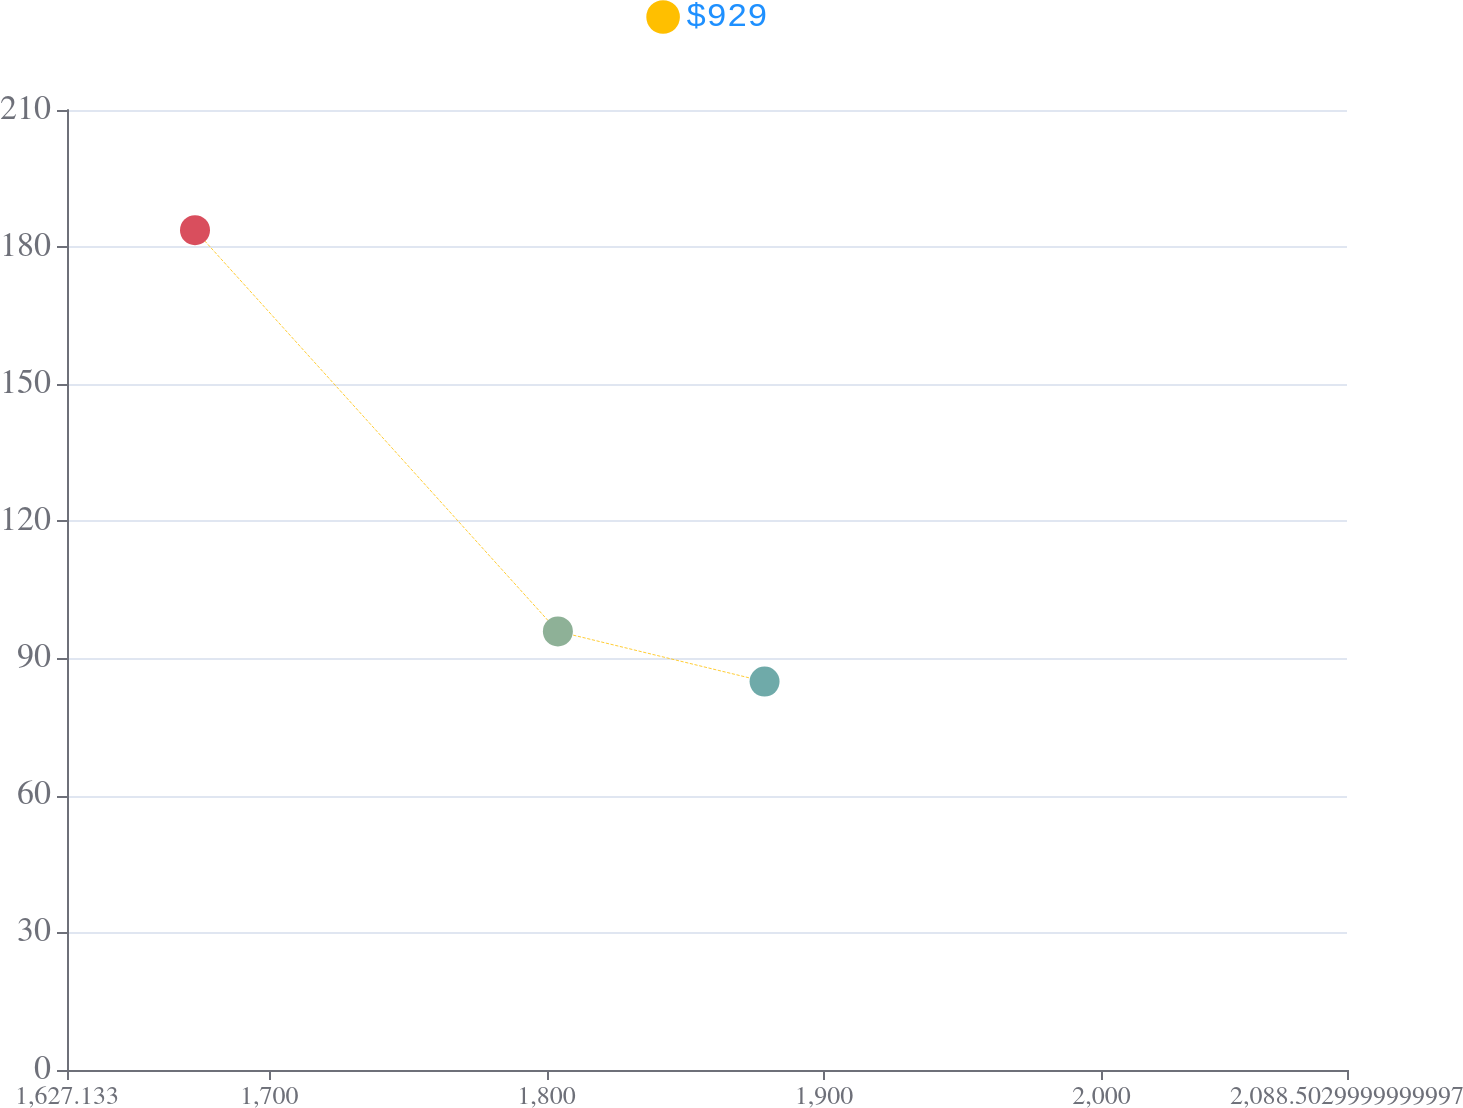Convert chart. <chart><loc_0><loc_0><loc_500><loc_500><line_chart><ecel><fcel>$929<nl><fcel>1673.27<fcel>183.72<nl><fcel>1804.07<fcel>95.94<nl><fcel>1878.57<fcel>84.97<nl><fcel>2134.64<fcel>74<nl></chart> 